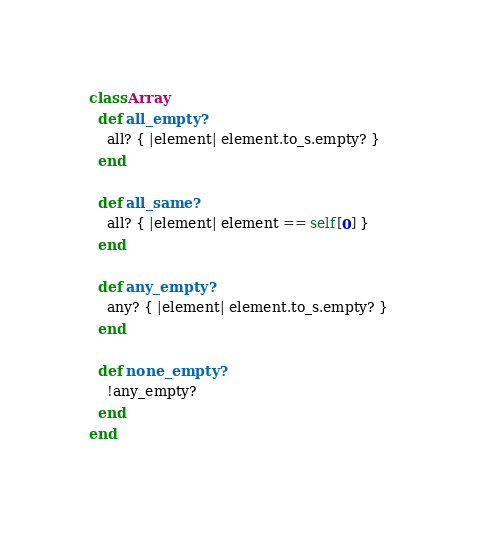Convert code to text. <code><loc_0><loc_0><loc_500><loc_500><_Ruby_>
class Array
  def all_empty?
    all? { |element| element.to_s.empty? }
  end

  def all_same?
    all? { |element| element == self[0] }
  end

  def any_empty?
    any? { |element| element.to_s.empty? }
  end

  def none_empty?
    !any_empty?
  end
end
</code> 